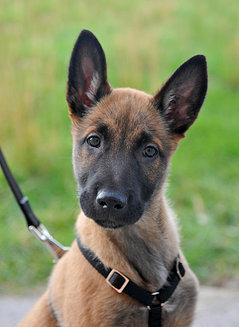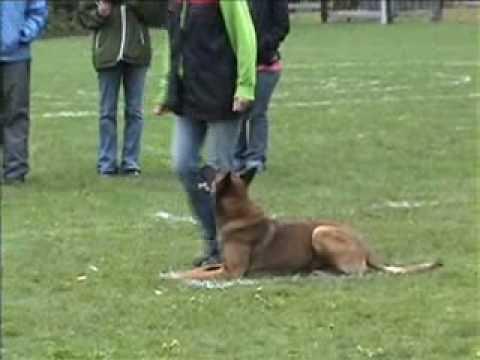The first image is the image on the left, the second image is the image on the right. Examine the images to the left and right. Is the description "An image shows someone wearing jeans standing behind a german shepherd dog." accurate? Answer yes or no. Yes. The first image is the image on the left, the second image is the image on the right. Evaluate the accuracy of this statement regarding the images: "The dog in the image on the right is lying in a grassy area.". Is it true? Answer yes or no. Yes. 